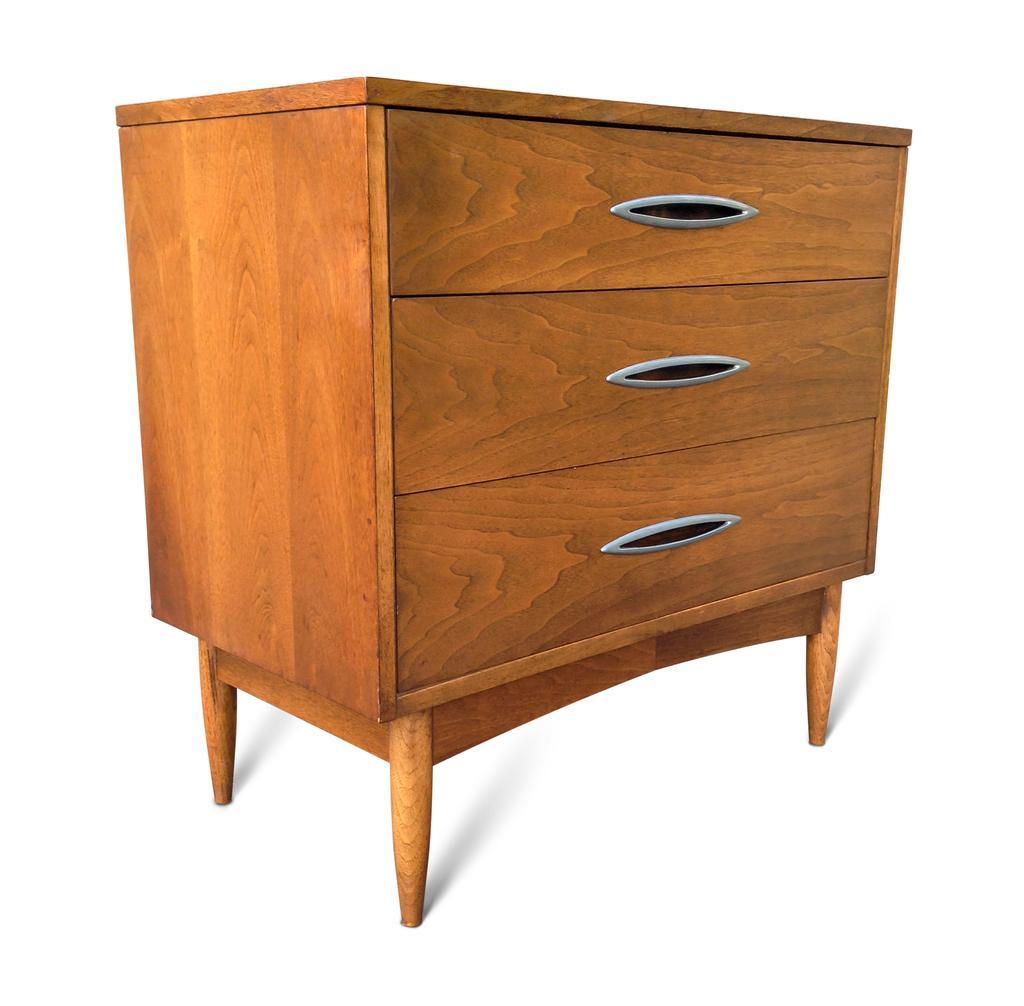Describe this image in one or two sentences. In this image there is a wooden cupboard with the three drawers. 